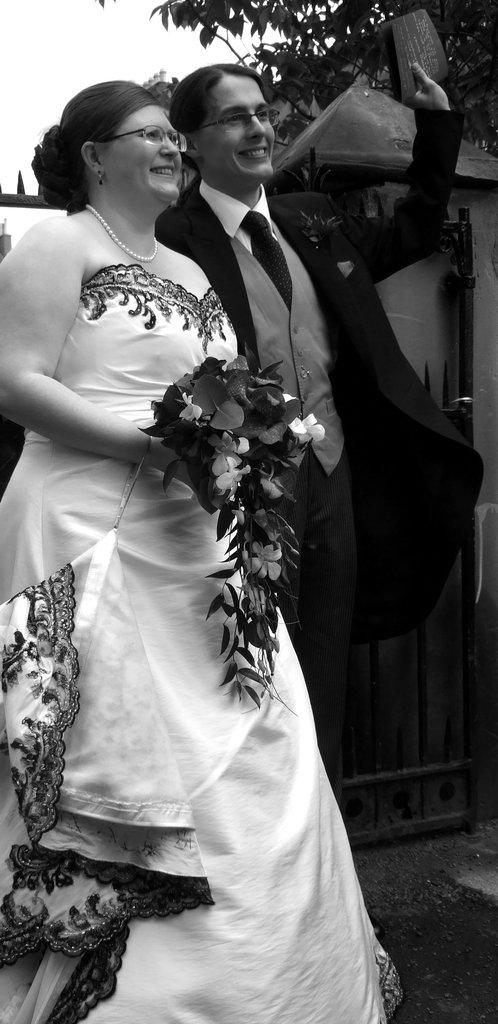What are the persons in the image doing? The persons in the image are holding a card and flowers. What can be seen in the background of the image? There is a gate in the wall, a tree, and the sky visible in the background of the image. What type of fiction is the person reading in the image? There is no person reading fiction in the image; the persons are holding a card and flowers. Can you see a flock of birds flying in the image? There is no flock of birds visible in the image; only the persons, card, flowers, gate, tree, and sky are present. 